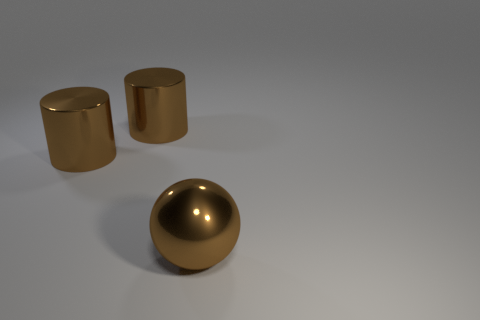Add 1 blue matte objects. How many objects exist? 4 Subtract all cylinders. How many objects are left? 1 Subtract all brown cylinders. Subtract all big brown metallic balls. How many objects are left? 0 Add 2 large brown metallic cylinders. How many large brown metallic cylinders are left? 4 Add 3 gray matte spheres. How many gray matte spheres exist? 3 Subtract 0 gray cylinders. How many objects are left? 3 Subtract 1 spheres. How many spheres are left? 0 Subtract all purple cylinders. Subtract all red blocks. How many cylinders are left? 2 Subtract all green balls. How many red cylinders are left? 0 